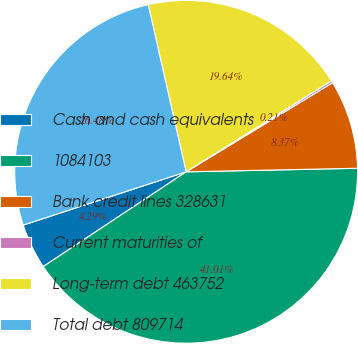<chart> <loc_0><loc_0><loc_500><loc_500><pie_chart><fcel>Cash and cash equivalents<fcel>1084103<fcel>Bank credit lines 328631<fcel>Current maturities of<fcel>Long-term debt 463752<fcel>Total debt 809714<nl><fcel>4.29%<fcel>41.01%<fcel>8.37%<fcel>0.21%<fcel>19.64%<fcel>26.48%<nl></chart> 